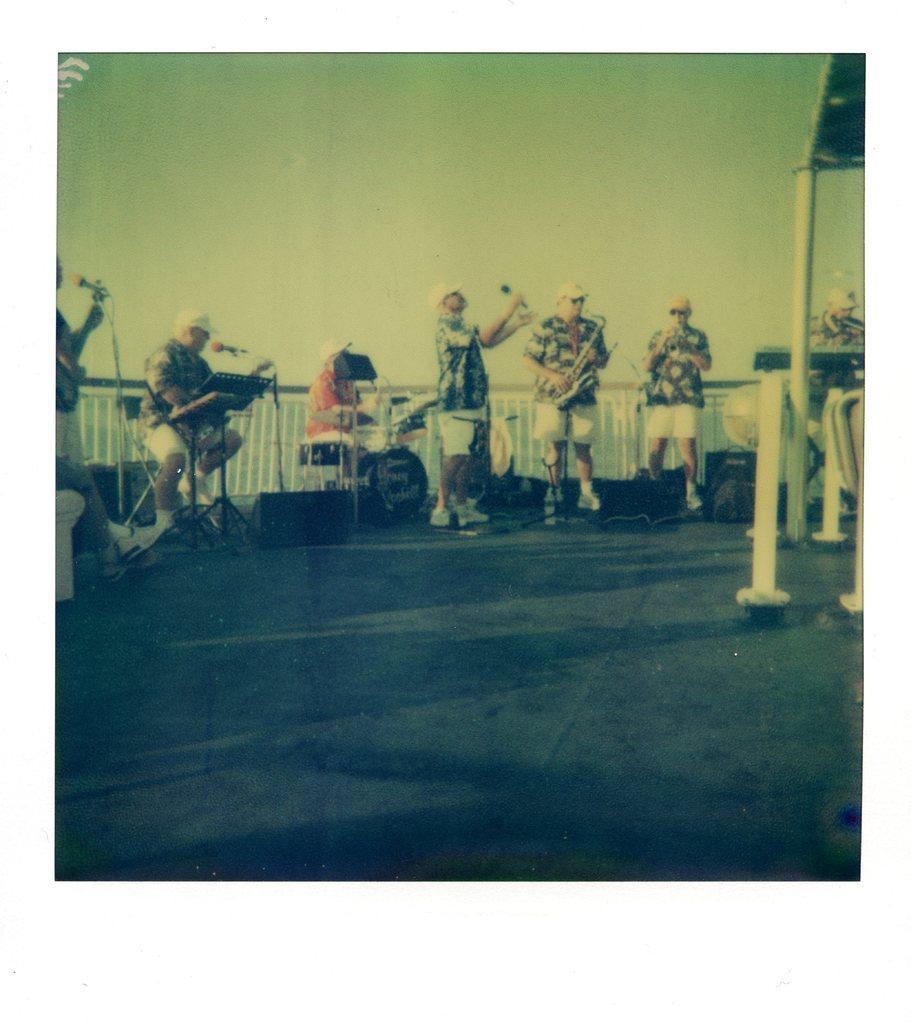Can you describe this image briefly? In this image there are persons standing, they are holding an object, there are musical instruments, there are stands, there are microphones, there is a person truncated the left of the image, there is an object truncated the left of the image, there are objects on the ground, there are objects truncated the right of the image, the background of the image is white in color. 